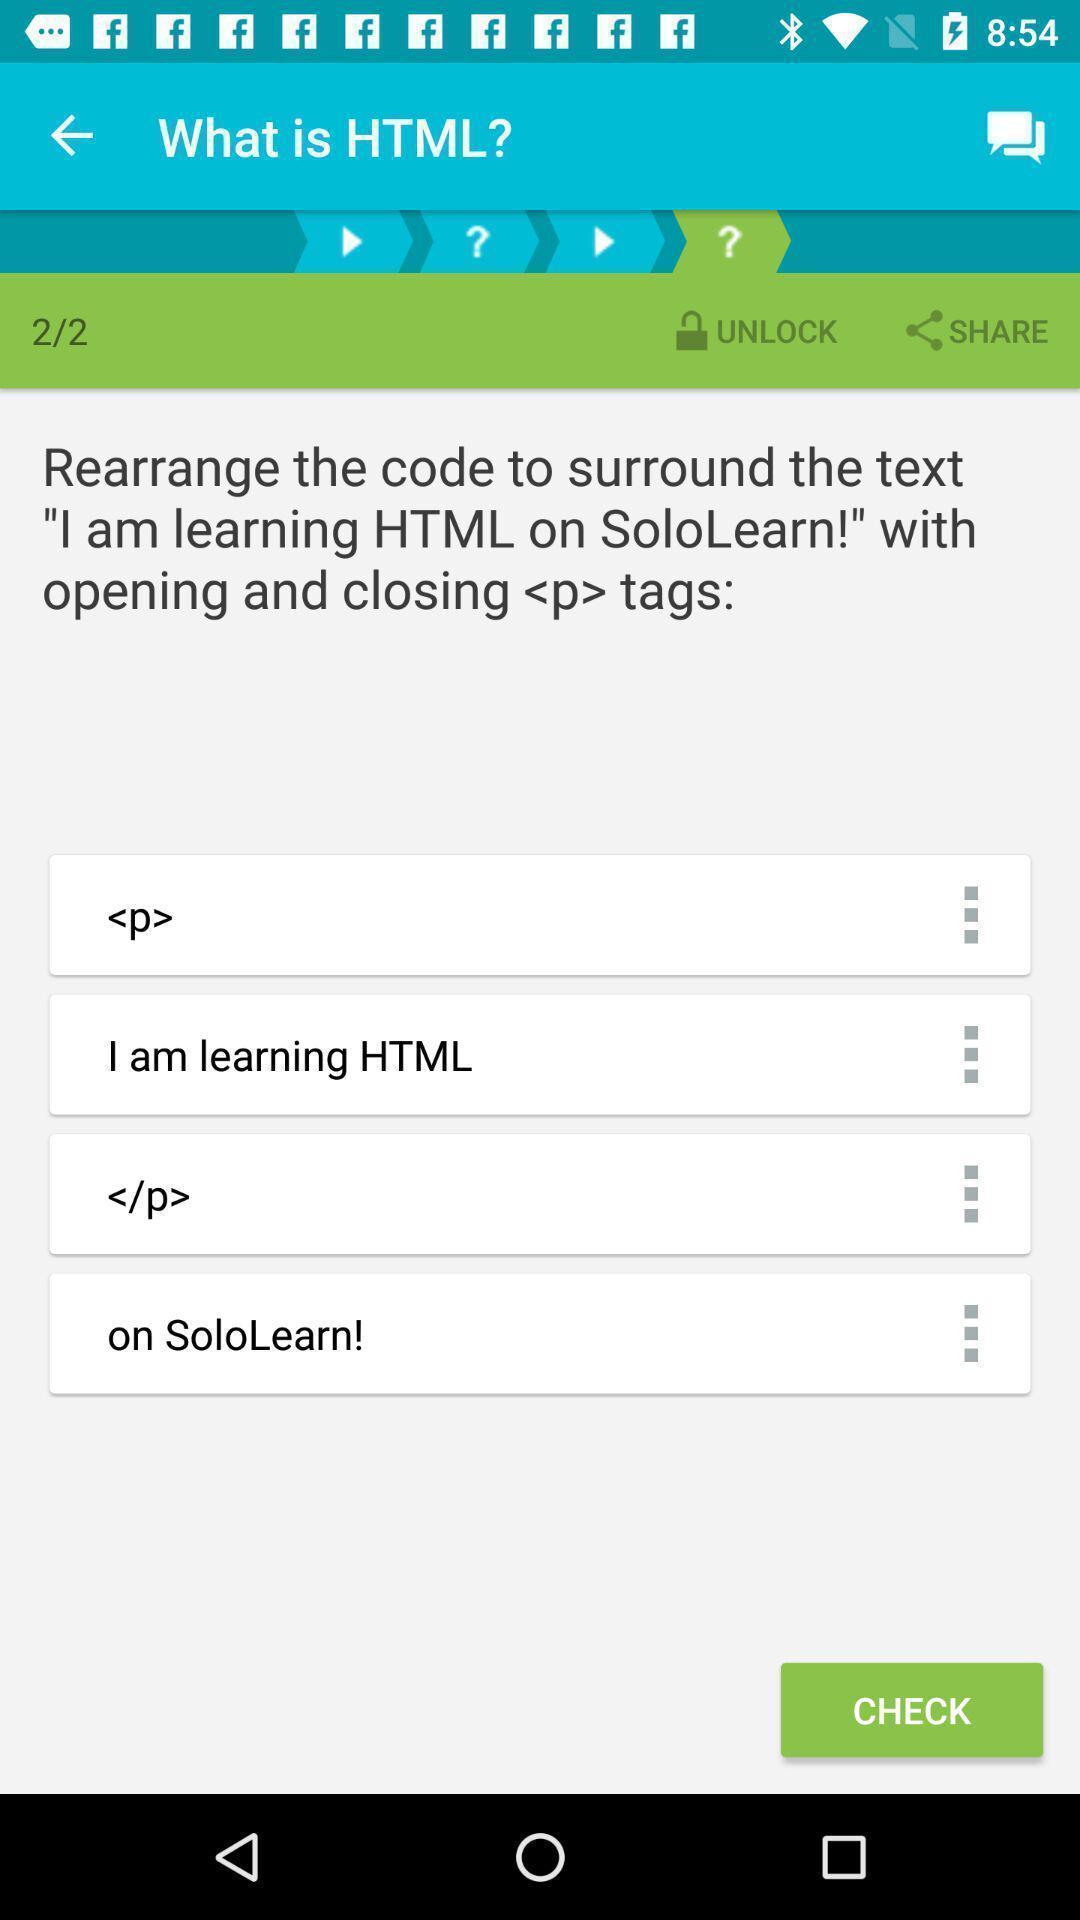Describe the visual elements of this screenshot. Screen page of a learning app. 